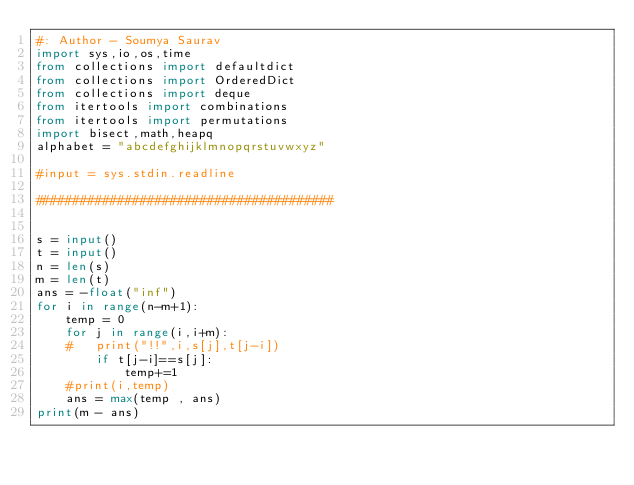Convert code to text. <code><loc_0><loc_0><loc_500><loc_500><_Python_>#: Author - Soumya Saurav
import sys,io,os,time
from collections import defaultdict
from collections import OrderedDict
from collections import deque
from itertools import combinations
from itertools import permutations
import bisect,math,heapq
alphabet = "abcdefghijklmnopqrstuvwxyz"

#input = sys.stdin.readline

########################################


s = input()
t = input()
n = len(s)
m = len(t)
ans = -float("inf")
for i in range(n-m+1):
	temp = 0
	for j in range(i,i+m):
	#	print("!!",i,s[j],t[j-i])
		if t[j-i]==s[j]:
			temp+=1
	#print(i,temp)
	ans = max(temp , ans)
print(m - ans)





</code> 